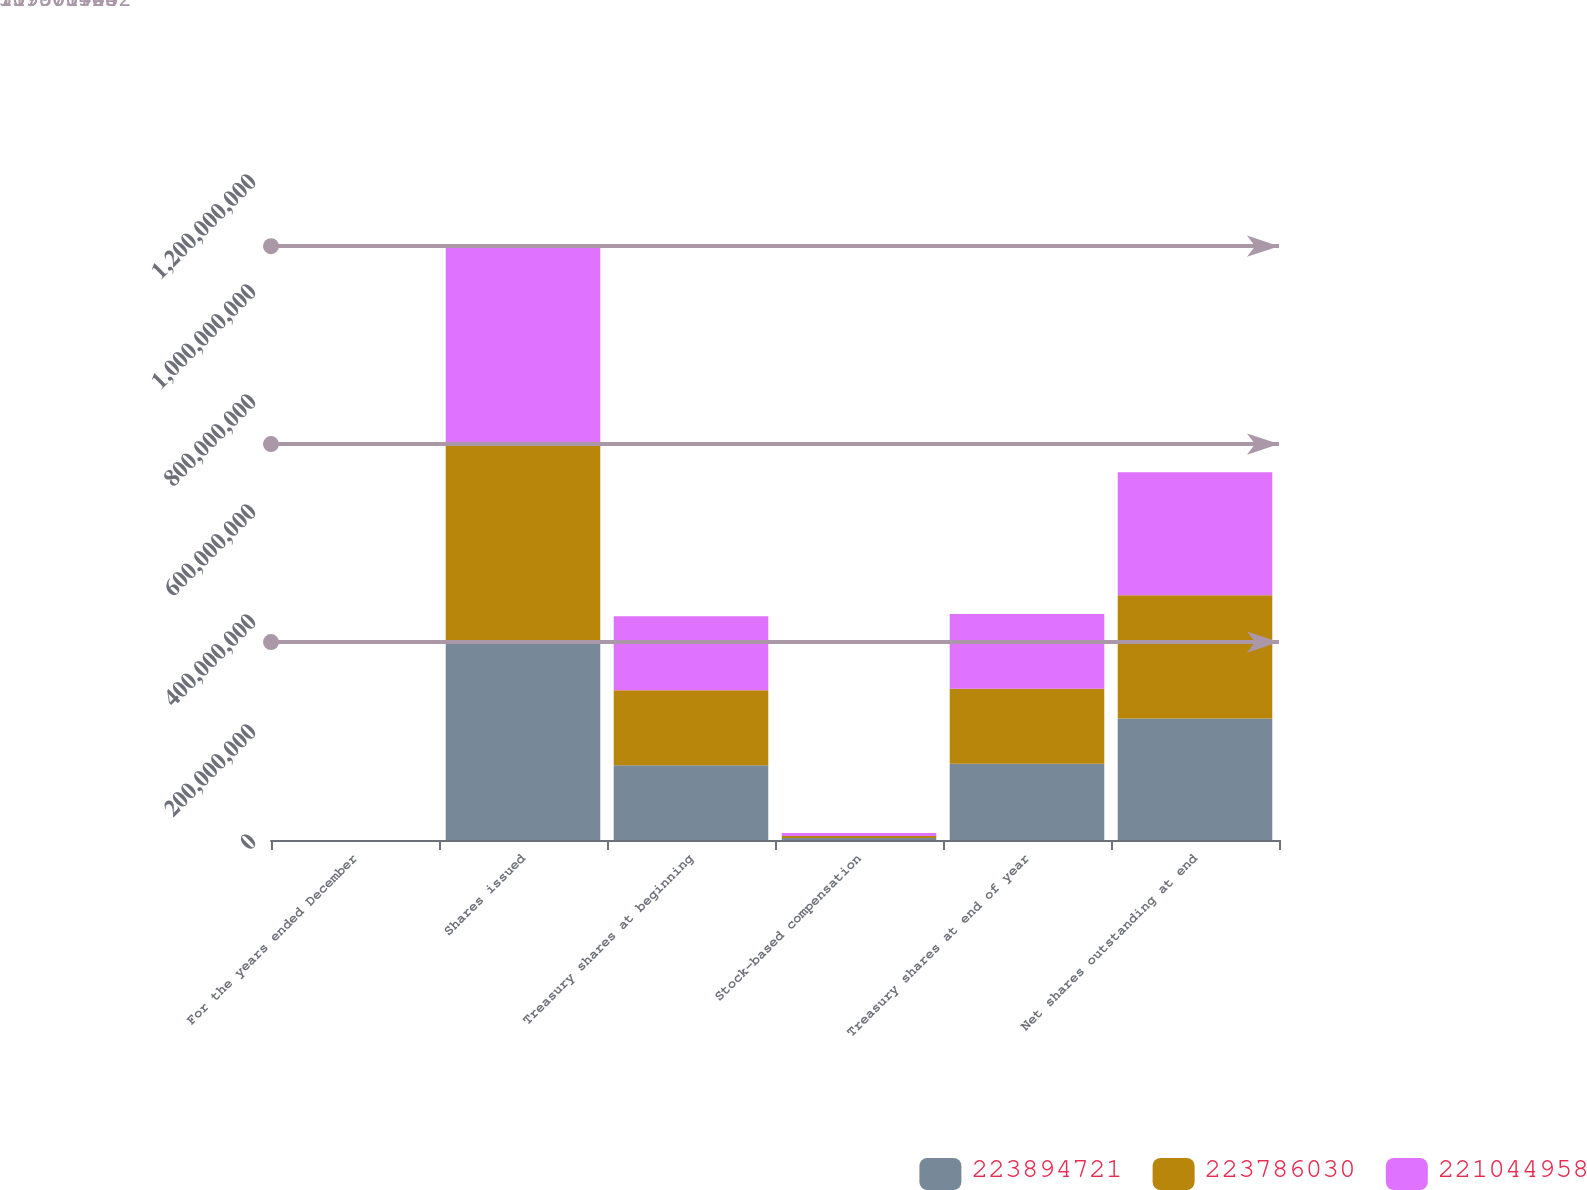<chart> <loc_0><loc_0><loc_500><loc_500><stacked_bar_chart><ecel><fcel>For the years ended December<fcel>Shares issued<fcel>Treasury shares at beginning<fcel>Stock-based compensation<fcel>Treasury shares at end of year<fcel>Net shares outstanding at end<nl><fcel>2.23895e+08<fcel>2014<fcel>3.59902e+08<fcel>1.36007e+08<fcel>3.67651e+06<fcel>1.38857e+08<fcel>2.21045e+08<nl><fcel>2.23786e+08<fcel>2013<fcel>3.59902e+08<fcel>1.36116e+08<fcel>3.65583e+06<fcel>1.36007e+08<fcel>2.23895e+08<nl><fcel>2.21045e+08<fcel>2012<fcel>3.59902e+08<fcel>1.34696e+08<fcel>5.59854e+06<fcel>1.36116e+08<fcel>2.23786e+08<nl></chart> 